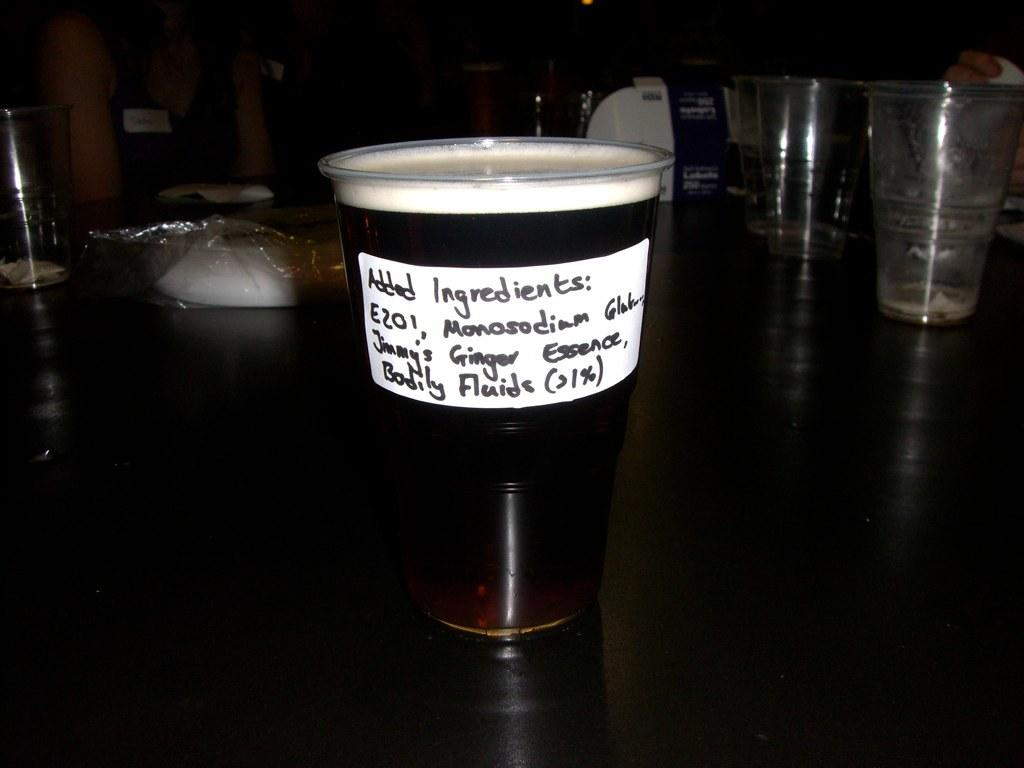Provide a one-sentence caption for the provided image. Someone took a cup of beer and added ingredients to it. 